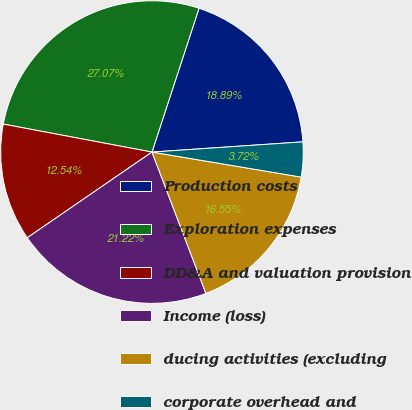<chart> <loc_0><loc_0><loc_500><loc_500><pie_chart><fcel>Production costs<fcel>Exploration expenses<fcel>DD&A and valuation provision<fcel>Income (loss)<fcel>ducing activities (excluding<fcel>corporate overhead and<nl><fcel>18.89%<fcel>27.07%<fcel>12.54%<fcel>21.22%<fcel>16.55%<fcel>3.72%<nl></chart> 